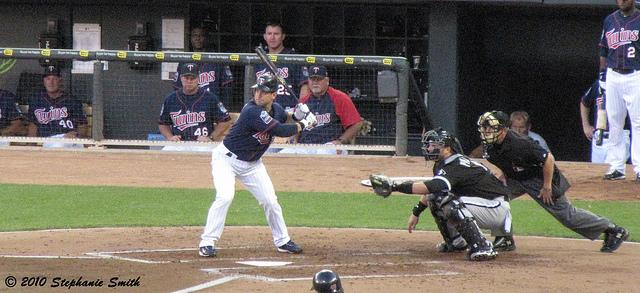What state is the batter's team located in?

Choices:
A) new jersey
B) minnesota
C) new york
D) illinois minnesota 